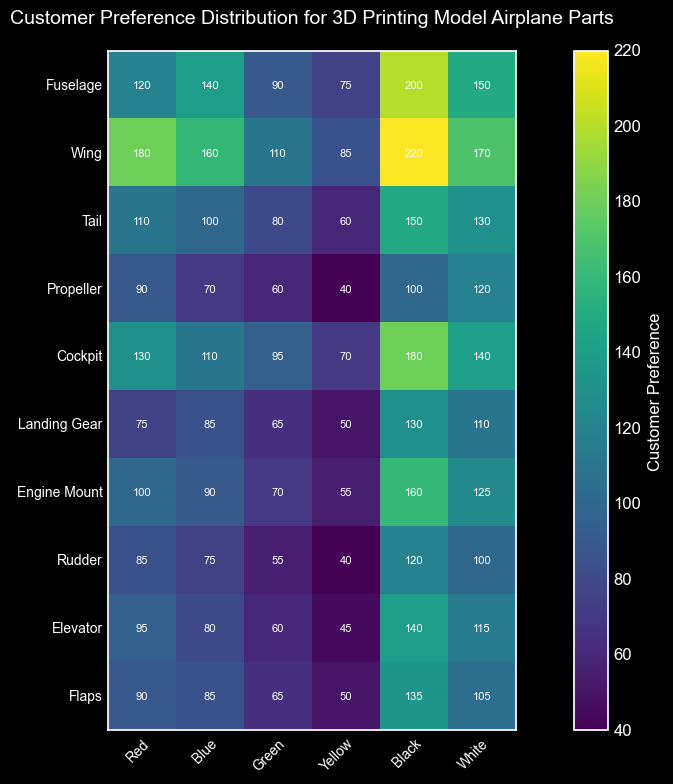Which part type has the highest customer preference for the color black? The plot shows customer preferences for different part types and colors. By looking at the column for "Black," we observe that "Wing" has the highest value at 220.
Answer: Wing Between the colors red and blue, which color has a higher average preference for the Fuselage? To find this, we compare the values for the Fuselage: Red (120) and Blue (140). Blue has a higher value.
Answer: Blue What is the total customer preference for the Cockpit part across all colors? The values for the Cockpit are: Red (130), Blue (110), Green (95), Yellow (70), Black (180), White (140). Sum these values: 130 + 110 + 95 + 70 + 180 + 140 = 725.
Answer: 725 Compare the customer preference for the Engine Mount part in green to the Tail part in yellow. Which one is higher? The Engine Mount in green has a value of 70, and the Tail in yellow has a value of 60. Therefore, the preference for the Engine Mount in green is higher.
Answer: Engine Mount (Green) What is the difference in customer preference between the highest and lowest preferred colors for the Flaps part? The values for the Flaps part are: Red (90), Blue (85), Green (65), Yellow (50), Black (135), White (105). The highest preference is Black (135), and the lowest is Yellow (50). The difference is 135 - 50 = 85.
Answer: 85 Across all part types, how many have a customer preference of at least 150 for any color? By examining the heatmap, we look for part types with a value of at least 150 in any color. The parts meeting this criterion are Fuselage (Black, White), Wing (Black, White), Cockpit (Black), and Engine Mount (Black). In total, there are 4 part types.
Answer: 4 Which part type has the most uniformly distributed customer preference across different colors, and how can you tell? To determine uniform distribution, we look for part types where the values are close to each other across all colors. The "Landing Gear" values (75, 85, 65, 50, 130, 110) have relatively close values with fewer drastic differences, indicating a more uniform distribution.
Answer: Landing Gear 